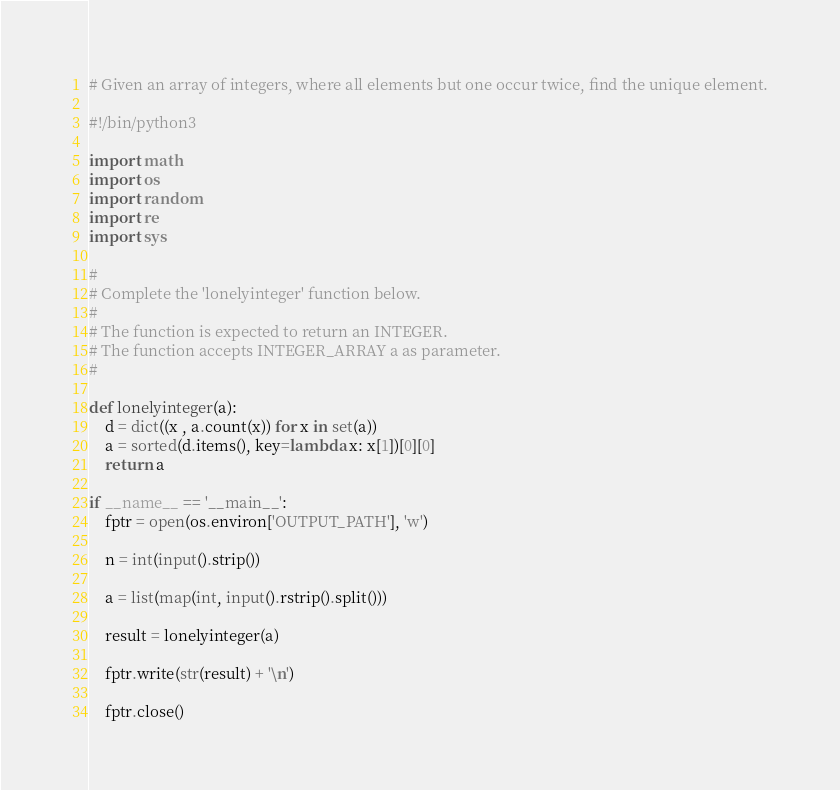<code> <loc_0><loc_0><loc_500><loc_500><_Python_># Given an array of integers, where all elements but one occur twice, find the unique element.

#!/bin/python3

import math
import os
import random
import re
import sys

#
# Complete the 'lonelyinteger' function below.
#
# The function is expected to return an INTEGER.
# The function accepts INTEGER_ARRAY a as parameter.
#

def lonelyinteger(a):
    d = dict((x , a.count(x)) for x in set(a))
    a = sorted(d.items(), key=lambda x: x[1])[0][0]  
    return a   

if __name__ == '__main__':
    fptr = open(os.environ['OUTPUT_PATH'], 'w')

    n = int(input().strip())

    a = list(map(int, input().rstrip().split()))

    result = lonelyinteger(a)

    fptr.write(str(result) + '\n')

    fptr.close()
</code> 